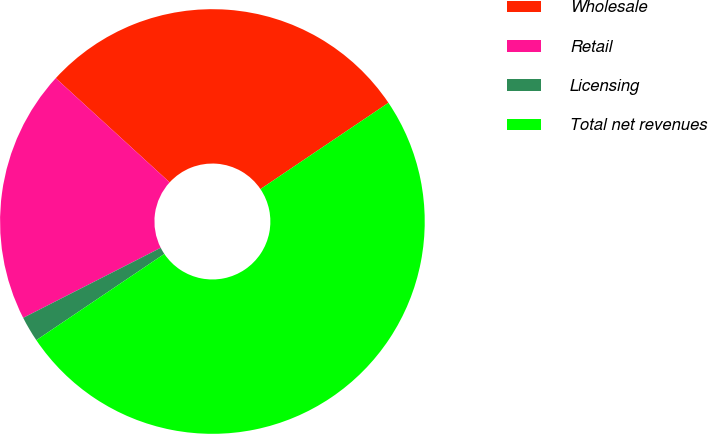Convert chart. <chart><loc_0><loc_0><loc_500><loc_500><pie_chart><fcel>Wholesale<fcel>Retail<fcel>Licensing<fcel>Total net revenues<nl><fcel>28.76%<fcel>19.29%<fcel>1.94%<fcel>50.0%<nl></chart> 